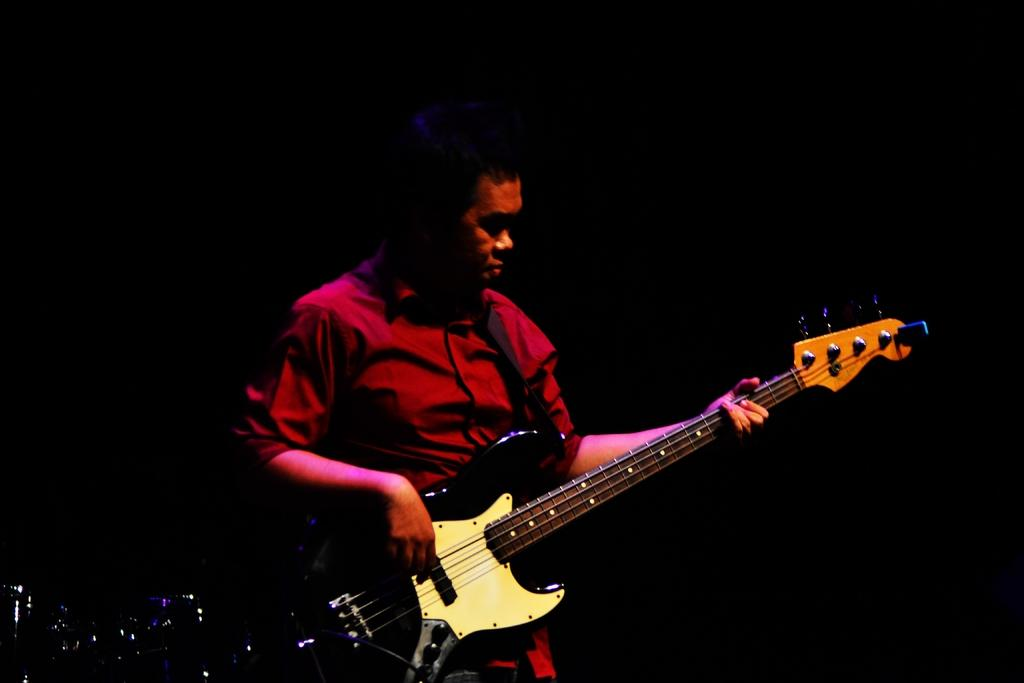Who is the main subject in the image? There is a person in the image. What is the person wearing? The person is wearing a red shirt. What object is the person holding? The person is holding a guitar. What is the person doing with the guitar? The person is playing the guitar. What type of screw can be seen in the image? There is no screw present in the image. Where is the person going on vacation in the image? There is no indication of a vacation in the image; it simply shows a person playing a guitar. 